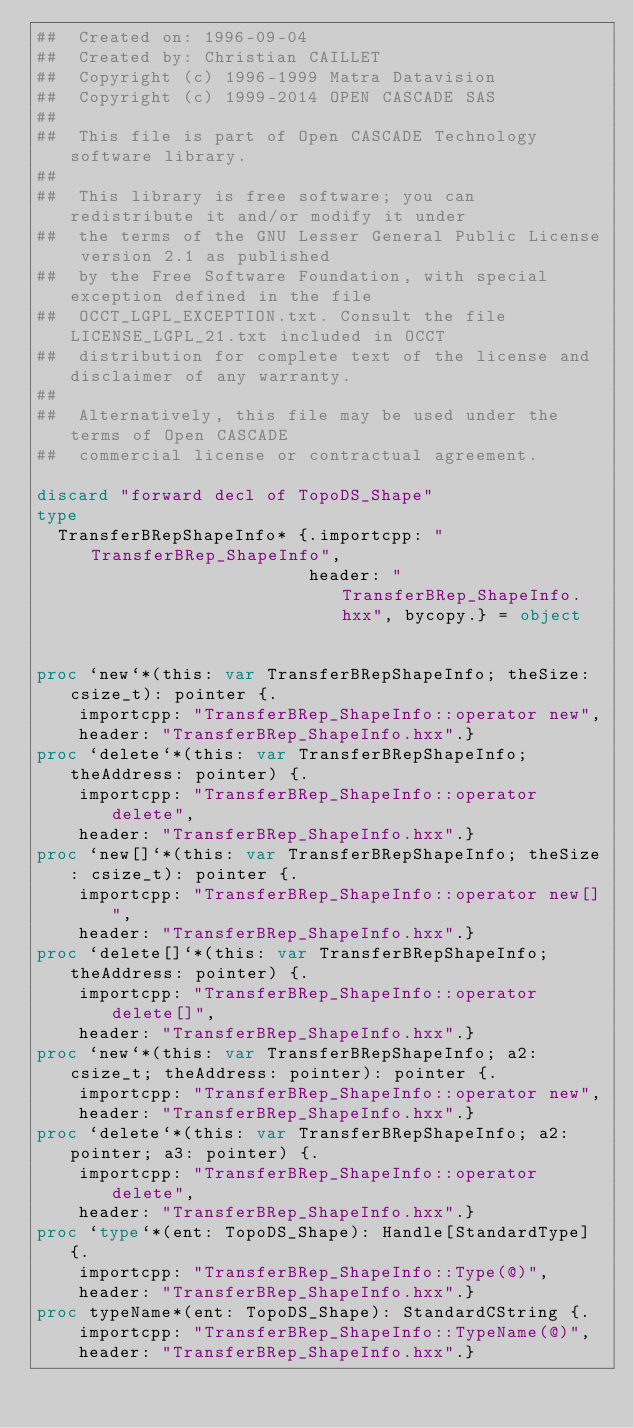<code> <loc_0><loc_0><loc_500><loc_500><_Nim_>##  Created on: 1996-09-04
##  Created by: Christian CAILLET
##  Copyright (c) 1996-1999 Matra Datavision
##  Copyright (c) 1999-2014 OPEN CASCADE SAS
##
##  This file is part of Open CASCADE Technology software library.
##
##  This library is free software; you can redistribute it and/or modify it under
##  the terms of the GNU Lesser General Public License version 2.1 as published
##  by the Free Software Foundation, with special exception defined in the file
##  OCCT_LGPL_EXCEPTION.txt. Consult the file LICENSE_LGPL_21.txt included in OCCT
##  distribution for complete text of the license and disclaimer of any warranty.
##
##  Alternatively, this file may be used under the terms of Open CASCADE
##  commercial license or contractual agreement.

discard "forward decl of TopoDS_Shape"
type
  TransferBRepShapeInfo* {.importcpp: "TransferBRep_ShapeInfo",
                          header: "TransferBRep_ShapeInfo.hxx", bycopy.} = object


proc `new`*(this: var TransferBRepShapeInfo; theSize: csize_t): pointer {.
    importcpp: "TransferBRep_ShapeInfo::operator new",
    header: "TransferBRep_ShapeInfo.hxx".}
proc `delete`*(this: var TransferBRepShapeInfo; theAddress: pointer) {.
    importcpp: "TransferBRep_ShapeInfo::operator delete",
    header: "TransferBRep_ShapeInfo.hxx".}
proc `new[]`*(this: var TransferBRepShapeInfo; theSize: csize_t): pointer {.
    importcpp: "TransferBRep_ShapeInfo::operator new[]",
    header: "TransferBRep_ShapeInfo.hxx".}
proc `delete[]`*(this: var TransferBRepShapeInfo; theAddress: pointer) {.
    importcpp: "TransferBRep_ShapeInfo::operator delete[]",
    header: "TransferBRep_ShapeInfo.hxx".}
proc `new`*(this: var TransferBRepShapeInfo; a2: csize_t; theAddress: pointer): pointer {.
    importcpp: "TransferBRep_ShapeInfo::operator new",
    header: "TransferBRep_ShapeInfo.hxx".}
proc `delete`*(this: var TransferBRepShapeInfo; a2: pointer; a3: pointer) {.
    importcpp: "TransferBRep_ShapeInfo::operator delete",
    header: "TransferBRep_ShapeInfo.hxx".}
proc `type`*(ent: TopoDS_Shape): Handle[StandardType] {.
    importcpp: "TransferBRep_ShapeInfo::Type(@)",
    header: "TransferBRep_ShapeInfo.hxx".}
proc typeName*(ent: TopoDS_Shape): StandardCString {.
    importcpp: "TransferBRep_ShapeInfo::TypeName(@)",
    header: "TransferBRep_ShapeInfo.hxx".}</code> 